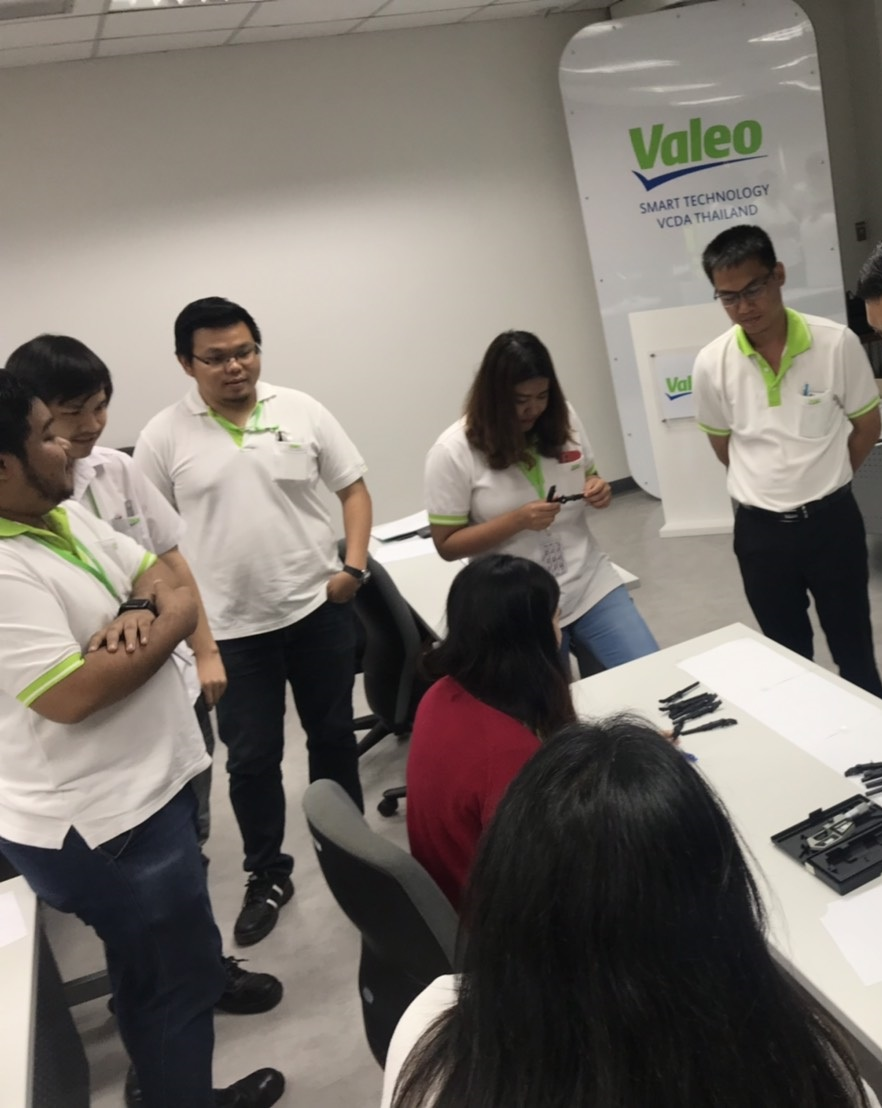Can you identify any specific roles or responsibilities that individuals in the image might have? The individuals in the image appear to have varied roles. For instance, the person standing with his hands folded could be a team leader or manager given his central position and attentive posture, indicating he is possibly overseeing the session. Others, who are also interacting with papers and pens, might be engineers, designers, or analysts, contributing their insights and expertise to the discussion. 